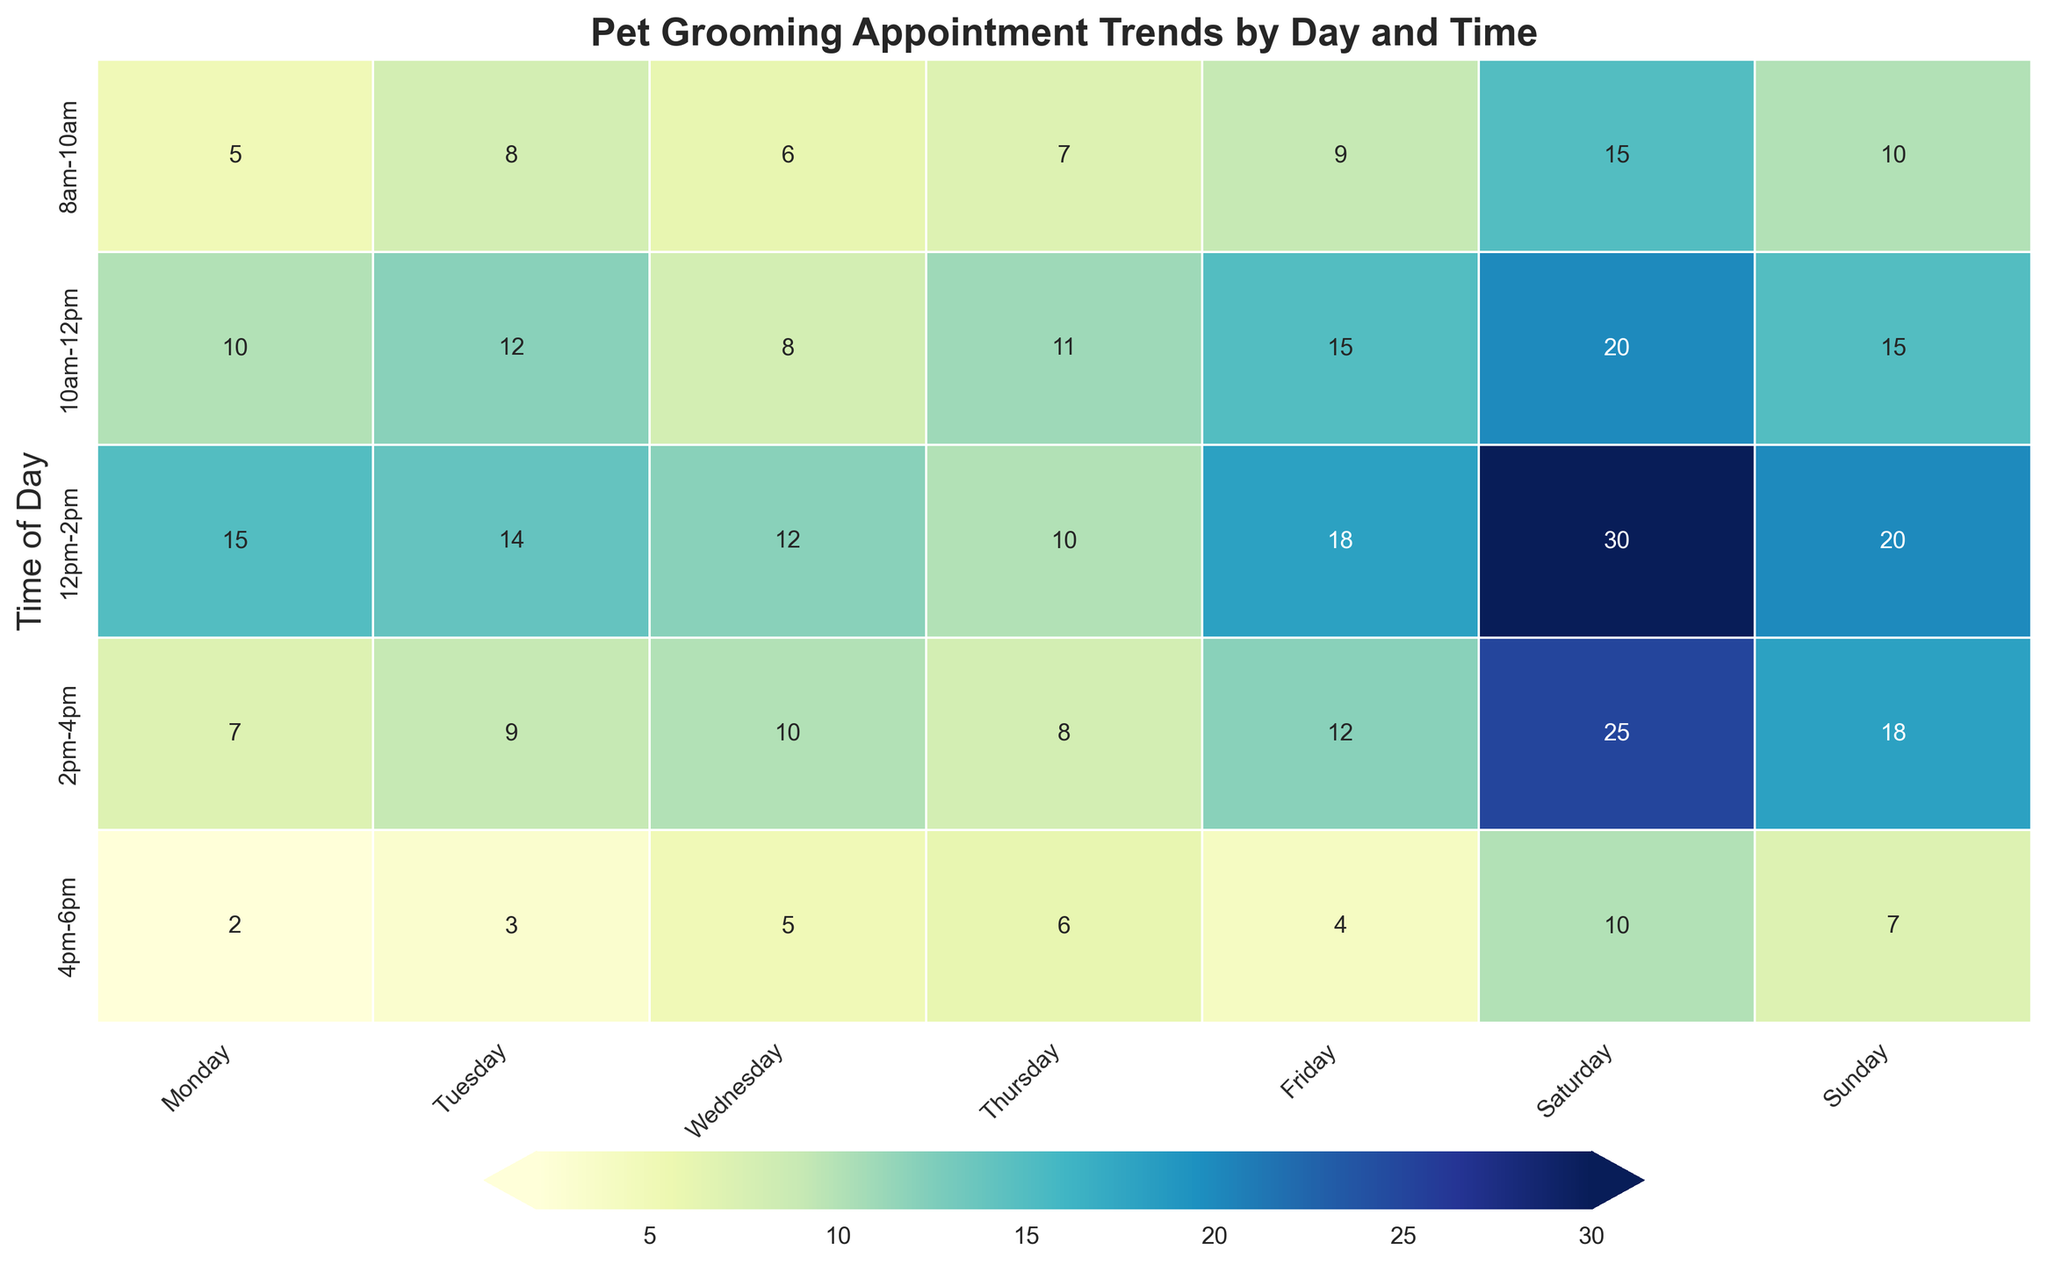What day of the week has the most pet grooming appointments in the 10am-12pm time slot? Looking at the intersection of the "10am-12pm" row and the "Day of the Week" columns, we see the highest value is 20 on Saturday. Thus, Saturday has the most appointments in this time slot.
Answer: Saturday Which time slot has the highest number of pet grooming appointments on Friday? In the "Friday" column, the highest value is 18. This value corresponds to the "12pm-2pm" time slot.
Answer: 12pm-2pm How does the number of appointments at 2pm-4pm on Wednesday compare to the number of appointments at the same time on Sunday? We compare the "2pm-4pm" values for Wednesday and Sunday: Wednesday has 10 appointments while Sunday has 18. Therefore, Sunday has more appointments than Wednesday in this time slot.
Answer: Sunday has more What is the total number of appointments on Friday? The values for Friday across all time slots are 9, 15, 18, 12, and 4. Summing these, we get 9 + 15 + 18 + 12 + 4 = 58.
Answer: 58 What day and time has the fewest total pet grooming appointments? By scanning the entire heatmap for the lowest value, we see the smallest number is 2, which occurs on Monday in the "4pm-6pm" time slot.
Answer: Monday, 4pm-6pm How many more appointments are there on Saturday compared to Tuesday for the 12pm-2pm time slot? The value for Saturday is 30, and for Tuesday, it is 14. The difference is 30 - 14 = 16.
Answer: 16 Which time slot generally has the highest number of appointments across all days? Examining the rows, the "12pm-2pm" time slot has the highest values across all days when summed up.
Answer: 12pm-2pm If we combine the number of appointments for the first and last time slots on Sunday, what is the total? Sunday has 10 appointments at "8am-10am" and 7 appointments at "4pm-6pm". The total is 10 + 7 = 17.
Answer: 17 